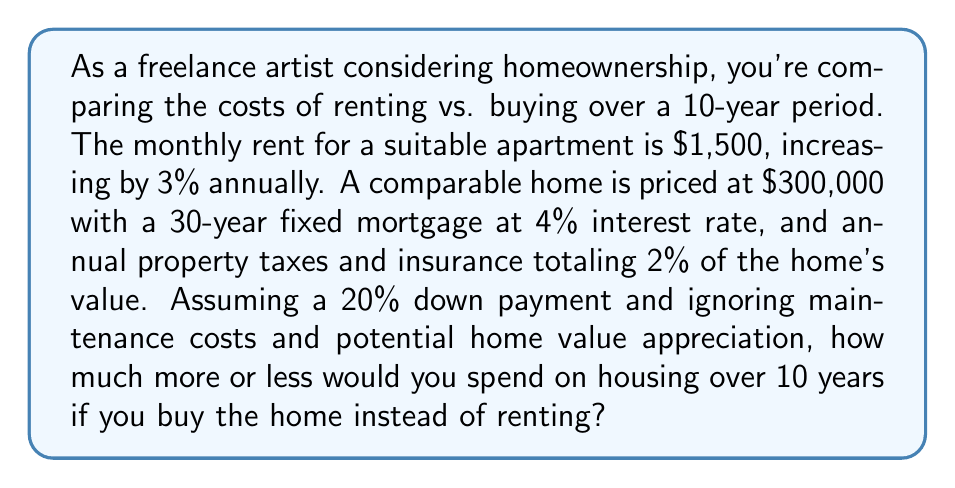Teach me how to tackle this problem. Let's break this down step-by-step:

1. Calculate the total cost of renting over 10 years:
   Let $r_n$ be the rent for year $n$.
   $r_1 = 1500 \times 12 = 18000$
   $r_n = r_{n-1} \times 1.03$ for $n = 2, 3, ..., 10$

   Total rent = $\sum_{n=1}^{10} r_n$

   $$\begin{align}
   r_1 &= 18000 \\
   r_2 &= 18540 \\
   r_3 &= 19096.20 \\
   &\vdots \\
   r_{10} &= 23465.84
   \end{align}$$

   Sum: $209,921.85

2. Calculate the total cost of buying over 10 years:
   a. Down payment: $300000 \times 0.20 = 60000$
   b. Loan amount: $300000 - 60000 = 240000$
   c. Monthly mortgage payment (P):
      $$P = L\frac{r(1+r)^n}{(1+r)^n-1}$$
      where $L = 240000$, $r = 0.04/12$, and $n = 360$
      $P = 1145.80$ per month

   d. Annual property taxes and insurance: $300000 \times 0.02 = 6000$

   e. Total monthly payment: $1145.80 + (6000/12) = 1645.80$
   f. Total paid over 10 years: $1645.80 \times 12 \times 10 = 197,496$

3. Compare the costs:
   Buying cost: $197,496
   Renting cost: $209,921.85
   Difference: $209,921.85 - 197,496 = 12,425.85$

Therefore, over 10 years, buying would save $12,425.85 compared to renting.
Answer: $12,425.85 less by buying 